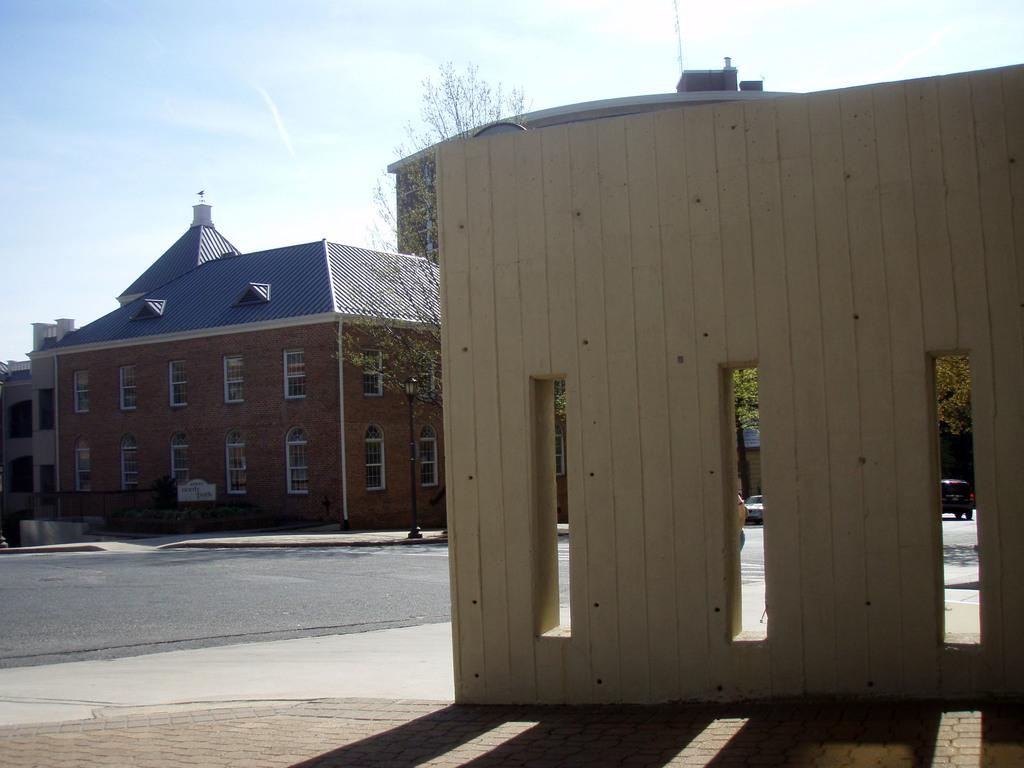What structure is located on the left side of the image? There is a building on the left side of the image. What can be seen on the right side of the image? There is a wall on the right side of the image. What activity is taking place in the morning in the image? There is no activity or reference to morning in the image; it only shows a building on the left side and a wall on the right side. Can you describe the arch in the image? There is no arch present in the image. 